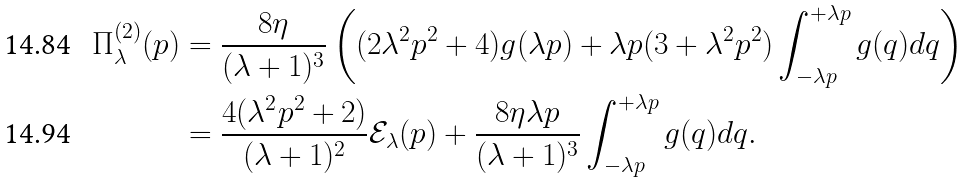<formula> <loc_0><loc_0><loc_500><loc_500>\Pi _ { \lambda } ^ { ( 2 ) } ( p ) & = \frac { 8 \eta } { ( \lambda + 1 ) ^ { 3 } } \left ( ( 2 \lambda ^ { 2 } p ^ { 2 } + 4 ) g ( \lambda p ) + \lambda p ( 3 + \lambda ^ { 2 } p ^ { 2 } ) \int _ { - \lambda p } ^ { + \lambda p } g ( q ) d q \right ) \\ & = \frac { 4 ( \lambda ^ { 2 } p ^ { 2 } + 2 ) } { ( \lambda + 1 ) ^ { 2 } } \mathcal { E } _ { \lambda } ( p ) + \frac { 8 \eta \lambda p } { ( \lambda + 1 ) ^ { 3 } } \int _ { - \lambda p } ^ { + \lambda p } g ( q ) d q .</formula> 